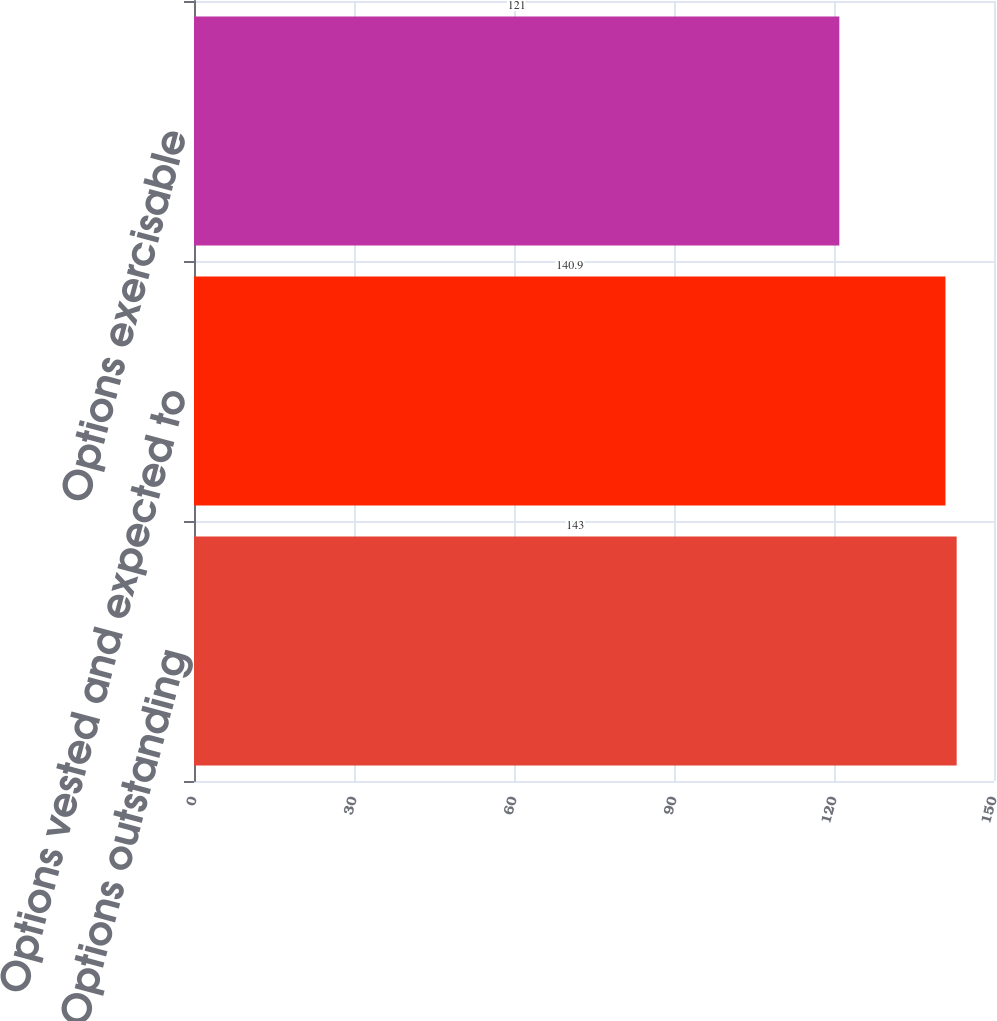Convert chart. <chart><loc_0><loc_0><loc_500><loc_500><bar_chart><fcel>Options outstanding<fcel>Options vested and expected to<fcel>Options exercisable<nl><fcel>143<fcel>140.9<fcel>121<nl></chart> 